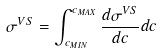<formula> <loc_0><loc_0><loc_500><loc_500>\sigma ^ { V S } = \int _ { c _ { M I N } } ^ { c _ { M A X } } \frac { d \sigma ^ { V S } } { d c } d c</formula> 